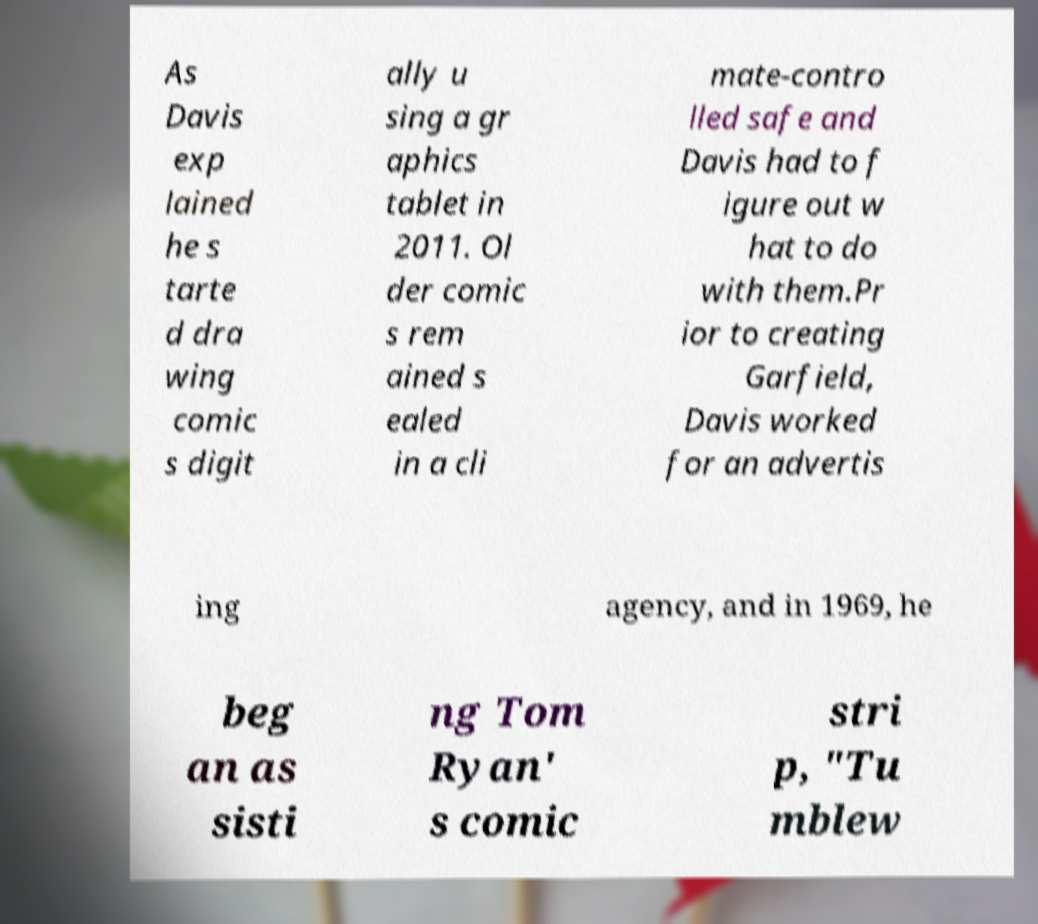There's text embedded in this image that I need extracted. Can you transcribe it verbatim? As Davis exp lained he s tarte d dra wing comic s digit ally u sing a gr aphics tablet in 2011. Ol der comic s rem ained s ealed in a cli mate-contro lled safe and Davis had to f igure out w hat to do with them.Pr ior to creating Garfield, Davis worked for an advertis ing agency, and in 1969, he beg an as sisti ng Tom Ryan' s comic stri p, "Tu mblew 